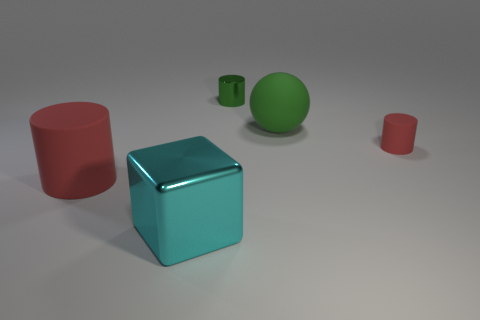What is the size of the thing that is the same color as the large rubber cylinder?
Offer a very short reply. Small. There is a metallic thing that is behind the large cyan metal object; how many things are in front of it?
Offer a very short reply. 4. Is the shape of the large rubber thing in front of the tiny red object the same as  the big green rubber thing?
Provide a succinct answer. No. There is another red object that is the same shape as the tiny red matte object; what material is it?
Provide a succinct answer. Rubber. How many metal objects are the same size as the green matte thing?
Make the answer very short. 1. There is a rubber object that is both to the right of the tiny metallic object and in front of the big green object; what is its color?
Provide a succinct answer. Red. Are there fewer big cylinders than tiny red metallic spheres?
Provide a succinct answer. No. Is the color of the sphere the same as the metal object that is behind the cyan cube?
Give a very brief answer. Yes. Is the number of big rubber cylinders behind the tiny red rubber cylinder the same as the number of big things behind the large rubber cylinder?
Provide a short and direct response. No. What number of other small cyan things have the same shape as the small rubber object?
Ensure brevity in your answer.  0. 